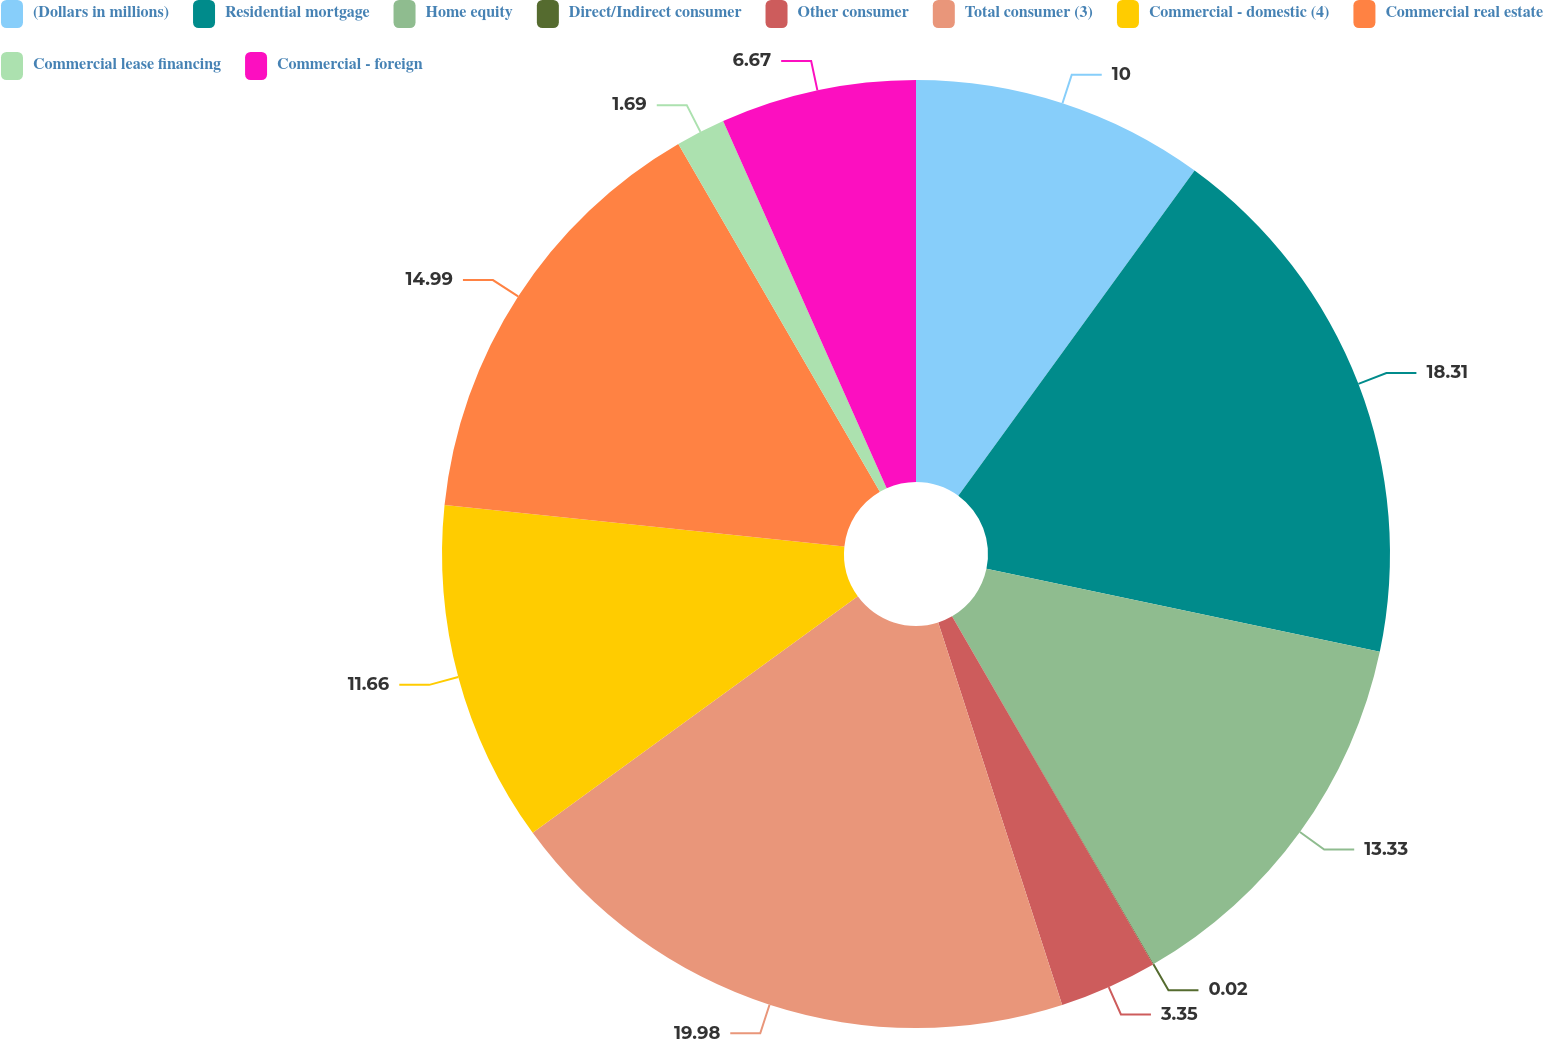Convert chart to OTSL. <chart><loc_0><loc_0><loc_500><loc_500><pie_chart><fcel>(Dollars in millions)<fcel>Residential mortgage<fcel>Home equity<fcel>Direct/Indirect consumer<fcel>Other consumer<fcel>Total consumer (3)<fcel>Commercial - domestic (4)<fcel>Commercial real estate<fcel>Commercial lease financing<fcel>Commercial - foreign<nl><fcel>10.0%<fcel>18.31%<fcel>13.33%<fcel>0.02%<fcel>3.35%<fcel>19.98%<fcel>11.66%<fcel>14.99%<fcel>1.69%<fcel>6.67%<nl></chart> 